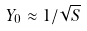Convert formula to latex. <formula><loc_0><loc_0><loc_500><loc_500>Y _ { 0 } \approx 1 / \sqrt { S }</formula> 